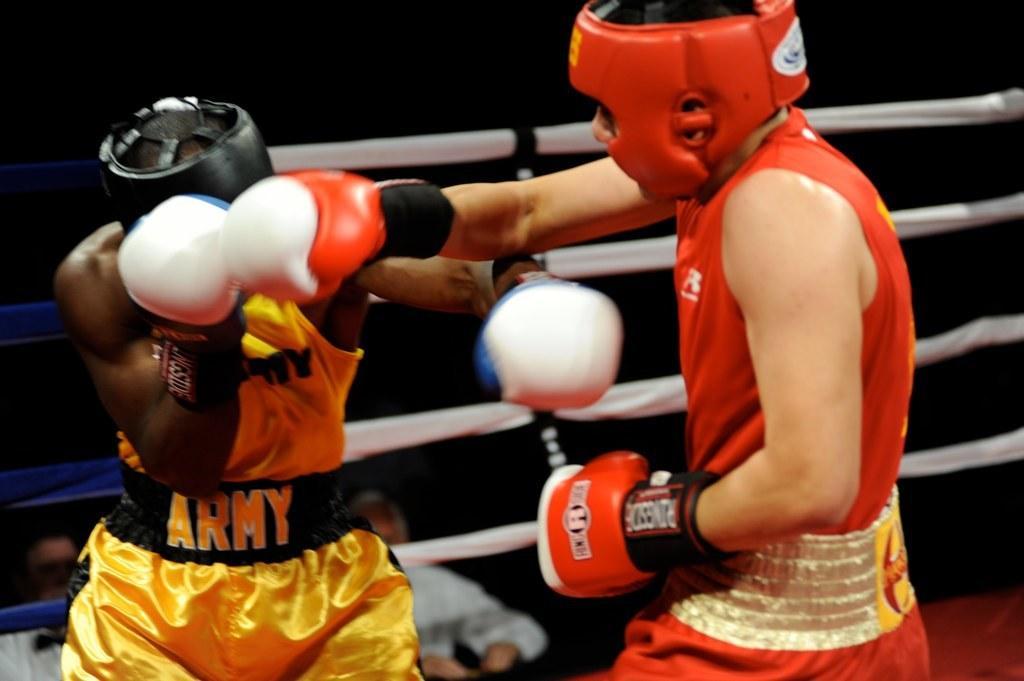In one or two sentences, can you explain what this image depicts? There are two persons in different color dresses, fighting on a stage. Beside them, there is a fence. In the background, there are two persons. And the background is dark in color. 